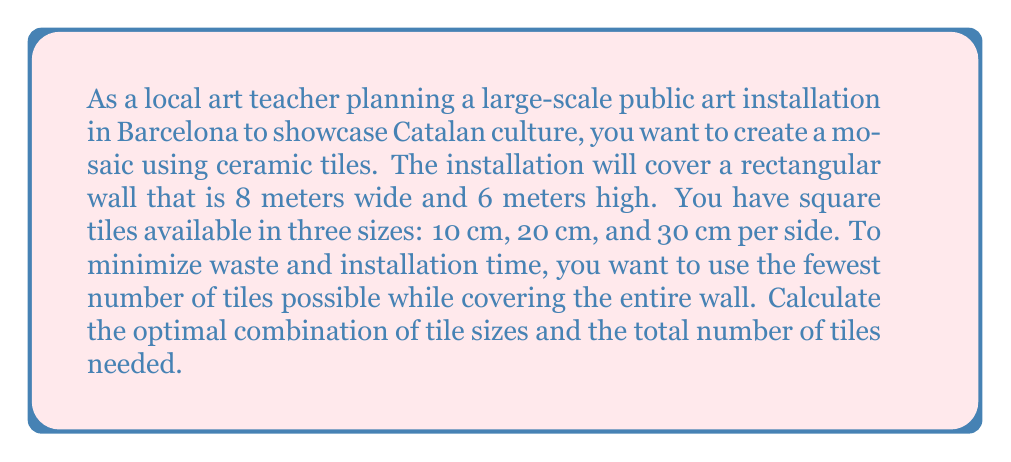Can you solve this math problem? Let's approach this problem step by step:

1) First, convert the wall dimensions to centimeters:
   Width = 8 m = 800 cm
   Height = 6 m = 600 cm

2) Define variables:
   Let $x$ = number of 10 cm tiles
   Let $y$ = number of 20 cm tiles
   Let $z$ = number of 30 cm tiles

3) Set up the objective function:
   Minimize $f(x,y,z) = x + y + z$

4) Constraints:
   The total area covered by the tiles must equal the wall area:
   $$(10 \cdot 10)x + (20 \cdot 20)y + (30 \cdot 30)z = 800 \cdot 600$$
   Simplifying: $100x + 400y + 900z = 480000$

5) This is an integer programming problem. The optimal solution will use only one tile size, as mixing sizes will always result in more total tiles.

6) Try each tile size:
   For 10 cm tiles: $x = 480000 / 100 = 4800$ tiles
   For 20 cm tiles: $y = 480000 / 400 = 1200$ tiles
   For 30 cm tiles: $z = 480000 / 900 \approx 533.33$ tiles

7) Since we can't use a fractional number of tiles, we need to round up for the 30 cm tiles:
   $z = 534$ tiles

8) Compare the total number of tiles for each option:
   10 cm: 4800 tiles
   20 cm: 1200 tiles
   30 cm: 534 tiles

Therefore, using 30 cm tiles results in the fewest total tiles.
Answer: The optimal solution is to use 534 tiles of 30 cm × 30 cm size. 